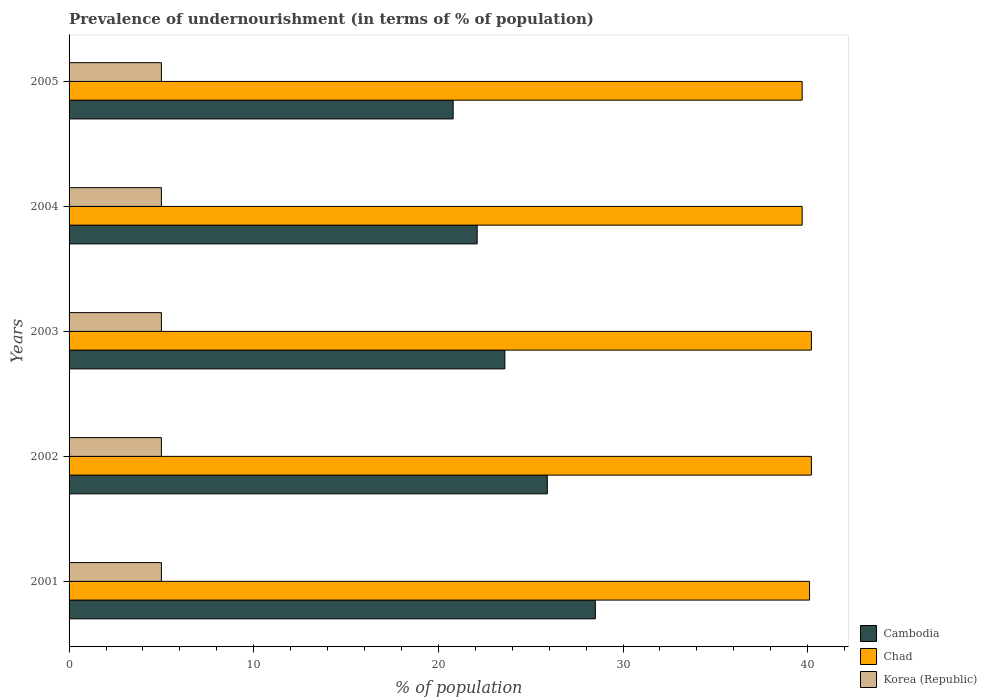How many different coloured bars are there?
Offer a terse response. 3. How many groups of bars are there?
Offer a terse response. 5. Are the number of bars on each tick of the Y-axis equal?
Your response must be concise. Yes. How many bars are there on the 4th tick from the bottom?
Keep it short and to the point. 3. What is the percentage of undernourished population in Korea (Republic) in 2002?
Your answer should be very brief. 5. Across all years, what is the maximum percentage of undernourished population in Korea (Republic)?
Your answer should be compact. 5. Across all years, what is the minimum percentage of undernourished population in Chad?
Give a very brief answer. 39.7. What is the total percentage of undernourished population in Cambodia in the graph?
Make the answer very short. 120.9. What is the difference between the percentage of undernourished population in Chad in 2001 and that in 2005?
Provide a short and direct response. 0.4. What is the difference between the percentage of undernourished population in Korea (Republic) in 2005 and the percentage of undernourished population in Cambodia in 2001?
Give a very brief answer. -23.5. What is the average percentage of undernourished population in Cambodia per year?
Offer a very short reply. 24.18. In the year 2005, what is the difference between the percentage of undernourished population in Chad and percentage of undernourished population in Cambodia?
Provide a succinct answer. 18.9. What is the ratio of the percentage of undernourished population in Korea (Republic) in 2001 to that in 2002?
Offer a very short reply. 1. What is the difference between the highest and the second highest percentage of undernourished population in Cambodia?
Give a very brief answer. 2.6. What is the difference between the highest and the lowest percentage of undernourished population in Chad?
Offer a terse response. 0.5. In how many years, is the percentage of undernourished population in Korea (Republic) greater than the average percentage of undernourished population in Korea (Republic) taken over all years?
Offer a terse response. 0. What does the 2nd bar from the top in 2004 represents?
Your response must be concise. Chad. What does the 1st bar from the bottom in 2004 represents?
Ensure brevity in your answer.  Cambodia. Is it the case that in every year, the sum of the percentage of undernourished population in Chad and percentage of undernourished population in Korea (Republic) is greater than the percentage of undernourished population in Cambodia?
Provide a short and direct response. Yes. Are all the bars in the graph horizontal?
Provide a succinct answer. Yes. How many years are there in the graph?
Your answer should be compact. 5. What is the difference between two consecutive major ticks on the X-axis?
Your answer should be compact. 10. Are the values on the major ticks of X-axis written in scientific E-notation?
Provide a succinct answer. No. Where does the legend appear in the graph?
Make the answer very short. Bottom right. What is the title of the graph?
Provide a succinct answer. Prevalence of undernourishment (in terms of % of population). Does "Bulgaria" appear as one of the legend labels in the graph?
Offer a terse response. No. What is the label or title of the X-axis?
Give a very brief answer. % of population. What is the % of population in Chad in 2001?
Your answer should be compact. 40.1. What is the % of population in Korea (Republic) in 2001?
Your answer should be very brief. 5. What is the % of population in Cambodia in 2002?
Offer a terse response. 25.9. What is the % of population of Chad in 2002?
Keep it short and to the point. 40.2. What is the % of population in Cambodia in 2003?
Ensure brevity in your answer.  23.6. What is the % of population in Chad in 2003?
Keep it short and to the point. 40.2. What is the % of population of Korea (Republic) in 2003?
Provide a succinct answer. 5. What is the % of population of Cambodia in 2004?
Your response must be concise. 22.1. What is the % of population of Chad in 2004?
Keep it short and to the point. 39.7. What is the % of population of Korea (Republic) in 2004?
Offer a terse response. 5. What is the % of population of Cambodia in 2005?
Ensure brevity in your answer.  20.8. What is the % of population of Chad in 2005?
Give a very brief answer. 39.7. What is the % of population in Korea (Republic) in 2005?
Your answer should be very brief. 5. Across all years, what is the maximum % of population in Cambodia?
Your answer should be very brief. 28.5. Across all years, what is the maximum % of population in Chad?
Your answer should be very brief. 40.2. Across all years, what is the maximum % of population of Korea (Republic)?
Provide a short and direct response. 5. Across all years, what is the minimum % of population of Cambodia?
Keep it short and to the point. 20.8. Across all years, what is the minimum % of population of Chad?
Provide a succinct answer. 39.7. What is the total % of population in Cambodia in the graph?
Provide a succinct answer. 120.9. What is the total % of population of Chad in the graph?
Ensure brevity in your answer.  199.9. What is the difference between the % of population of Cambodia in 2001 and that in 2002?
Ensure brevity in your answer.  2.6. What is the difference between the % of population in Chad in 2001 and that in 2002?
Your answer should be compact. -0.1. What is the difference between the % of population of Korea (Republic) in 2001 and that in 2002?
Offer a very short reply. 0. What is the difference between the % of population in Chad in 2001 and that in 2004?
Your answer should be compact. 0.4. What is the difference between the % of population in Korea (Republic) in 2001 and that in 2005?
Keep it short and to the point. 0. What is the difference between the % of population in Cambodia in 2002 and that in 2003?
Provide a short and direct response. 2.3. What is the difference between the % of population of Cambodia in 2002 and that in 2004?
Make the answer very short. 3.8. What is the difference between the % of population in Korea (Republic) in 2002 and that in 2004?
Keep it short and to the point. 0. What is the difference between the % of population of Cambodia in 2002 and that in 2005?
Ensure brevity in your answer.  5.1. What is the difference between the % of population in Cambodia in 2003 and that in 2004?
Your answer should be very brief. 1.5. What is the difference between the % of population in Chad in 2003 and that in 2005?
Your answer should be very brief. 0.5. What is the difference between the % of population of Cambodia in 2001 and the % of population of Korea (Republic) in 2002?
Give a very brief answer. 23.5. What is the difference between the % of population of Chad in 2001 and the % of population of Korea (Republic) in 2002?
Give a very brief answer. 35.1. What is the difference between the % of population in Cambodia in 2001 and the % of population in Chad in 2003?
Provide a succinct answer. -11.7. What is the difference between the % of population in Chad in 2001 and the % of population in Korea (Republic) in 2003?
Offer a very short reply. 35.1. What is the difference between the % of population in Cambodia in 2001 and the % of population in Chad in 2004?
Make the answer very short. -11.2. What is the difference between the % of population in Chad in 2001 and the % of population in Korea (Republic) in 2004?
Provide a short and direct response. 35.1. What is the difference between the % of population of Chad in 2001 and the % of population of Korea (Republic) in 2005?
Your answer should be very brief. 35.1. What is the difference between the % of population of Cambodia in 2002 and the % of population of Chad in 2003?
Your answer should be very brief. -14.3. What is the difference between the % of population of Cambodia in 2002 and the % of population of Korea (Republic) in 2003?
Your response must be concise. 20.9. What is the difference between the % of population of Chad in 2002 and the % of population of Korea (Republic) in 2003?
Your answer should be very brief. 35.2. What is the difference between the % of population of Cambodia in 2002 and the % of population of Korea (Republic) in 2004?
Offer a very short reply. 20.9. What is the difference between the % of population of Chad in 2002 and the % of population of Korea (Republic) in 2004?
Offer a terse response. 35.2. What is the difference between the % of population in Cambodia in 2002 and the % of population in Chad in 2005?
Your response must be concise. -13.8. What is the difference between the % of population of Cambodia in 2002 and the % of population of Korea (Republic) in 2005?
Your answer should be compact. 20.9. What is the difference between the % of population of Chad in 2002 and the % of population of Korea (Republic) in 2005?
Your response must be concise. 35.2. What is the difference between the % of population in Cambodia in 2003 and the % of population in Chad in 2004?
Ensure brevity in your answer.  -16.1. What is the difference between the % of population in Chad in 2003 and the % of population in Korea (Republic) in 2004?
Offer a very short reply. 35.2. What is the difference between the % of population in Cambodia in 2003 and the % of population in Chad in 2005?
Provide a short and direct response. -16.1. What is the difference between the % of population of Chad in 2003 and the % of population of Korea (Republic) in 2005?
Keep it short and to the point. 35.2. What is the difference between the % of population of Cambodia in 2004 and the % of population of Chad in 2005?
Your response must be concise. -17.6. What is the difference between the % of population in Chad in 2004 and the % of population in Korea (Republic) in 2005?
Make the answer very short. 34.7. What is the average % of population in Cambodia per year?
Offer a terse response. 24.18. What is the average % of population of Chad per year?
Make the answer very short. 39.98. In the year 2001, what is the difference between the % of population in Cambodia and % of population in Chad?
Your answer should be very brief. -11.6. In the year 2001, what is the difference between the % of population of Cambodia and % of population of Korea (Republic)?
Your response must be concise. 23.5. In the year 2001, what is the difference between the % of population of Chad and % of population of Korea (Republic)?
Give a very brief answer. 35.1. In the year 2002, what is the difference between the % of population of Cambodia and % of population of Chad?
Keep it short and to the point. -14.3. In the year 2002, what is the difference between the % of population in Cambodia and % of population in Korea (Republic)?
Provide a succinct answer. 20.9. In the year 2002, what is the difference between the % of population of Chad and % of population of Korea (Republic)?
Give a very brief answer. 35.2. In the year 2003, what is the difference between the % of population of Cambodia and % of population of Chad?
Offer a terse response. -16.6. In the year 2003, what is the difference between the % of population of Cambodia and % of population of Korea (Republic)?
Give a very brief answer. 18.6. In the year 2003, what is the difference between the % of population of Chad and % of population of Korea (Republic)?
Offer a terse response. 35.2. In the year 2004, what is the difference between the % of population of Cambodia and % of population of Chad?
Offer a terse response. -17.6. In the year 2004, what is the difference between the % of population in Cambodia and % of population in Korea (Republic)?
Provide a succinct answer. 17.1. In the year 2004, what is the difference between the % of population in Chad and % of population in Korea (Republic)?
Give a very brief answer. 34.7. In the year 2005, what is the difference between the % of population in Cambodia and % of population in Chad?
Your answer should be very brief. -18.9. In the year 2005, what is the difference between the % of population of Cambodia and % of population of Korea (Republic)?
Make the answer very short. 15.8. In the year 2005, what is the difference between the % of population in Chad and % of population in Korea (Republic)?
Your answer should be very brief. 34.7. What is the ratio of the % of population of Cambodia in 2001 to that in 2002?
Your response must be concise. 1.1. What is the ratio of the % of population of Cambodia in 2001 to that in 2003?
Your answer should be compact. 1.21. What is the ratio of the % of population of Chad in 2001 to that in 2003?
Provide a succinct answer. 1. What is the ratio of the % of population in Cambodia in 2001 to that in 2004?
Provide a short and direct response. 1.29. What is the ratio of the % of population in Korea (Republic) in 2001 to that in 2004?
Keep it short and to the point. 1. What is the ratio of the % of population in Cambodia in 2001 to that in 2005?
Offer a very short reply. 1.37. What is the ratio of the % of population in Cambodia in 2002 to that in 2003?
Your answer should be very brief. 1.1. What is the ratio of the % of population of Chad in 2002 to that in 2003?
Offer a terse response. 1. What is the ratio of the % of population of Korea (Republic) in 2002 to that in 2003?
Give a very brief answer. 1. What is the ratio of the % of population in Cambodia in 2002 to that in 2004?
Offer a very short reply. 1.17. What is the ratio of the % of population in Chad in 2002 to that in 2004?
Provide a short and direct response. 1.01. What is the ratio of the % of population in Korea (Republic) in 2002 to that in 2004?
Your answer should be very brief. 1. What is the ratio of the % of population in Cambodia in 2002 to that in 2005?
Your response must be concise. 1.25. What is the ratio of the % of population in Chad in 2002 to that in 2005?
Give a very brief answer. 1.01. What is the ratio of the % of population in Korea (Republic) in 2002 to that in 2005?
Your answer should be compact. 1. What is the ratio of the % of population of Cambodia in 2003 to that in 2004?
Offer a terse response. 1.07. What is the ratio of the % of population in Chad in 2003 to that in 2004?
Give a very brief answer. 1.01. What is the ratio of the % of population of Cambodia in 2003 to that in 2005?
Offer a terse response. 1.13. What is the ratio of the % of population of Chad in 2003 to that in 2005?
Your answer should be very brief. 1.01. What is the ratio of the % of population in Korea (Republic) in 2003 to that in 2005?
Your response must be concise. 1. What is the ratio of the % of population of Cambodia in 2004 to that in 2005?
Ensure brevity in your answer.  1.06. What is the ratio of the % of population in Korea (Republic) in 2004 to that in 2005?
Your response must be concise. 1. What is the difference between the highest and the second highest % of population of Cambodia?
Provide a succinct answer. 2.6. What is the difference between the highest and the second highest % of population of Korea (Republic)?
Offer a terse response. 0. What is the difference between the highest and the lowest % of population of Cambodia?
Keep it short and to the point. 7.7. What is the difference between the highest and the lowest % of population in Korea (Republic)?
Your answer should be very brief. 0. 